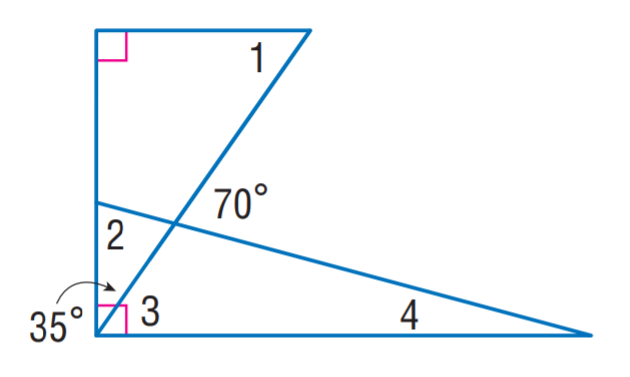Answer the mathemtical geometry problem and directly provide the correct option letter.
Question: Find m \angle 4.
Choices: A: 10 B: 15 C: 35 D: 55 B 